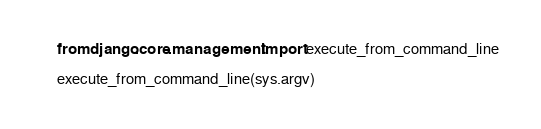Convert code to text. <code><loc_0><loc_0><loc_500><loc_500><_Python_>
    from django.core.management import execute_from_command_line

    execute_from_command_line(sys.argv)
</code> 